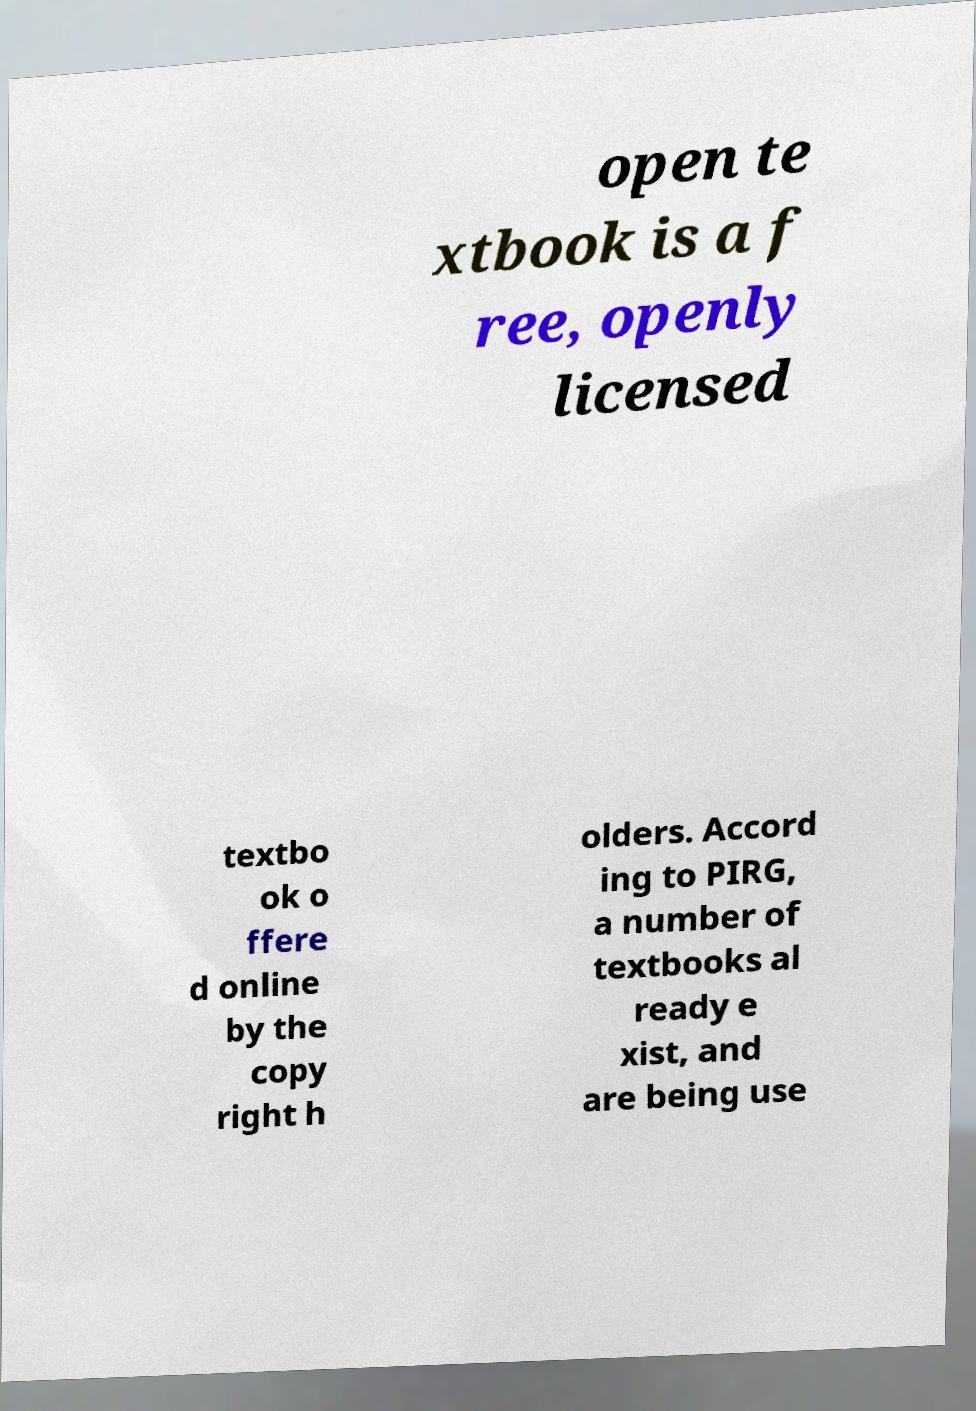What messages or text are displayed in this image? I need them in a readable, typed format. open te xtbook is a f ree, openly licensed textbo ok o ffere d online by the copy right h olders. Accord ing to PIRG, a number of textbooks al ready e xist, and are being use 